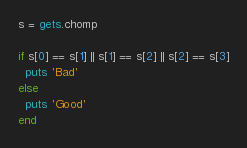<code> <loc_0><loc_0><loc_500><loc_500><_Ruby_>s = gets.chomp

if s[0] == s[1] || s[1] == s[2] || s[2] == s[3]
  puts 'Bad'
else
  puts 'Good'
end</code> 